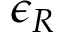Convert formula to latex. <formula><loc_0><loc_0><loc_500><loc_500>\epsilon _ { R }</formula> 